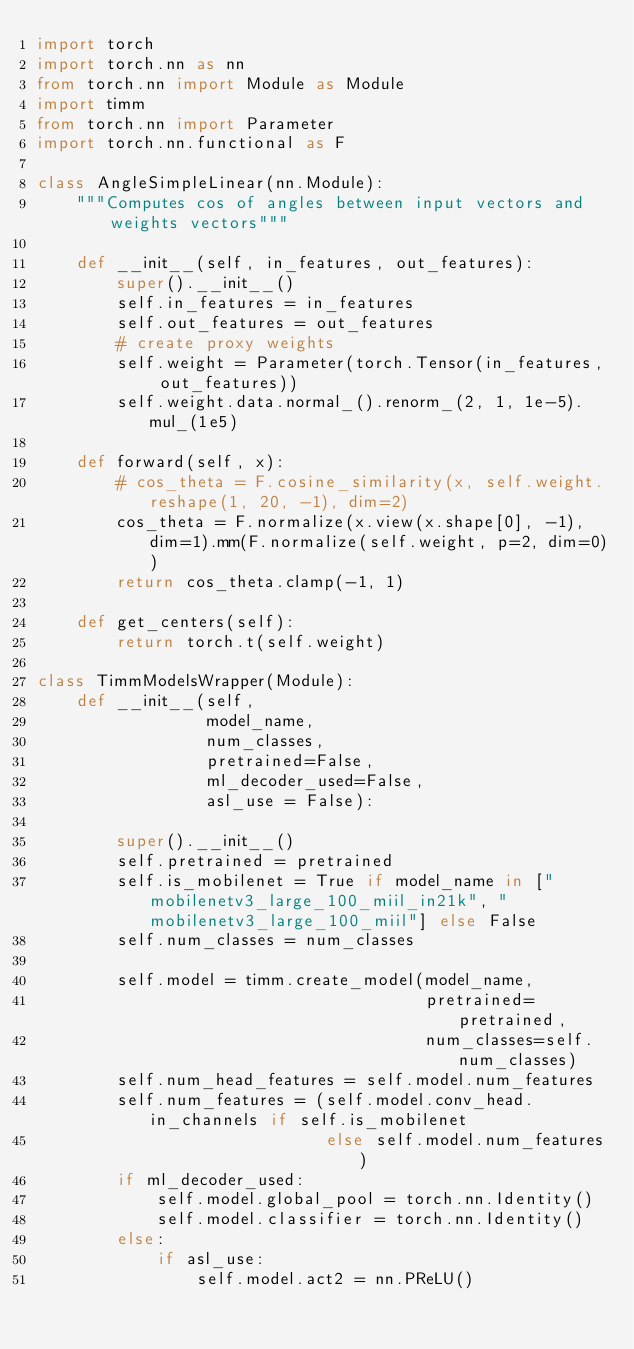<code> <loc_0><loc_0><loc_500><loc_500><_Python_>import torch
import torch.nn as nn
from torch.nn import Module as Module
import timm
from torch.nn import Parameter
import torch.nn.functional as F

class AngleSimpleLinear(nn.Module):
    """Computes cos of angles between input vectors and weights vectors"""

    def __init__(self, in_features, out_features):
        super().__init__()
        self.in_features = in_features
        self.out_features = out_features
        # create proxy weights
        self.weight = Parameter(torch.Tensor(in_features, out_features))
        self.weight.data.normal_().renorm_(2, 1, 1e-5).mul_(1e5)

    def forward(self, x):
        # cos_theta = F.cosine_similarity(x, self.weight.reshape(1, 20, -1), dim=2)
        cos_theta = F.normalize(x.view(x.shape[0], -1), dim=1).mm(F.normalize(self.weight, p=2, dim=0))
        return cos_theta.clamp(-1, 1)

    def get_centers(self):
        return torch.t(self.weight)

class TimmModelsWrapper(Module):
    def __init__(self,
                 model_name,
                 num_classes,
                 pretrained=False,
                 ml_decoder_used=False,
                 asl_use = False):

        super().__init__()
        self.pretrained = pretrained
        self.is_mobilenet = True if model_name in ["mobilenetv3_large_100_miil_in21k", "mobilenetv3_large_100_miil"] else False
        self.num_classes = num_classes

        self.model = timm.create_model(model_name,
                                       pretrained=pretrained,
                                       num_classes=self.num_classes)
        self.num_head_features = self.model.num_features
        self.num_features = (self.model.conv_head.in_channels if self.is_mobilenet
                             else self.model.num_features)
        if ml_decoder_used:
            self.model.global_pool = torch.nn.Identity()
            self.model.classifier = torch.nn.Identity()
        else:
            if asl_use:
                self.model.act2 = nn.PReLU()</code> 